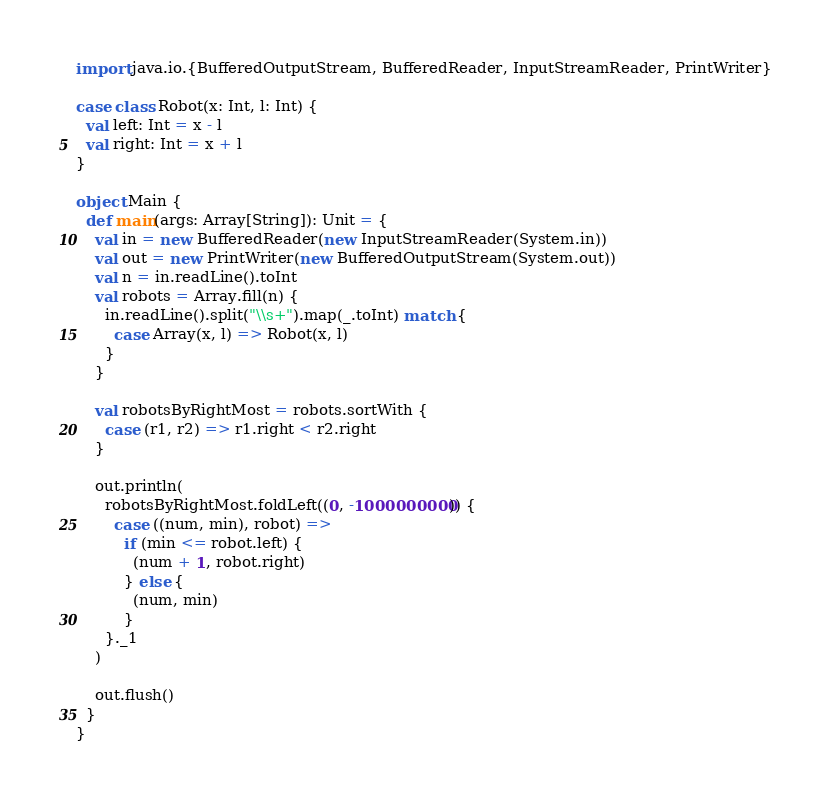<code> <loc_0><loc_0><loc_500><loc_500><_Scala_>import java.io.{BufferedOutputStream, BufferedReader, InputStreamReader, PrintWriter}

case class Robot(x: Int, l: Int) {
  val left: Int = x - l
  val right: Int = x + l
}

object Main {
  def main(args: Array[String]): Unit = {
    val in = new BufferedReader(new InputStreamReader(System.in))
    val out = new PrintWriter(new BufferedOutputStream(System.out))
    val n = in.readLine().toInt
    val robots = Array.fill(n) {
      in.readLine().split("\\s+").map(_.toInt) match {
        case Array(x, l) => Robot(x, l)
      }
    }

    val robotsByRightMost = robots.sortWith {
      case (r1, r2) => r1.right < r2.right
    }

    out.println(
      robotsByRightMost.foldLeft((0, -1000000000)) {
        case ((num, min), robot) =>
          if (min <= robot.left) {
            (num + 1, robot.right)
          } else {
            (num, min)
          }
      }._1
    )

    out.flush()
  }
}
</code> 